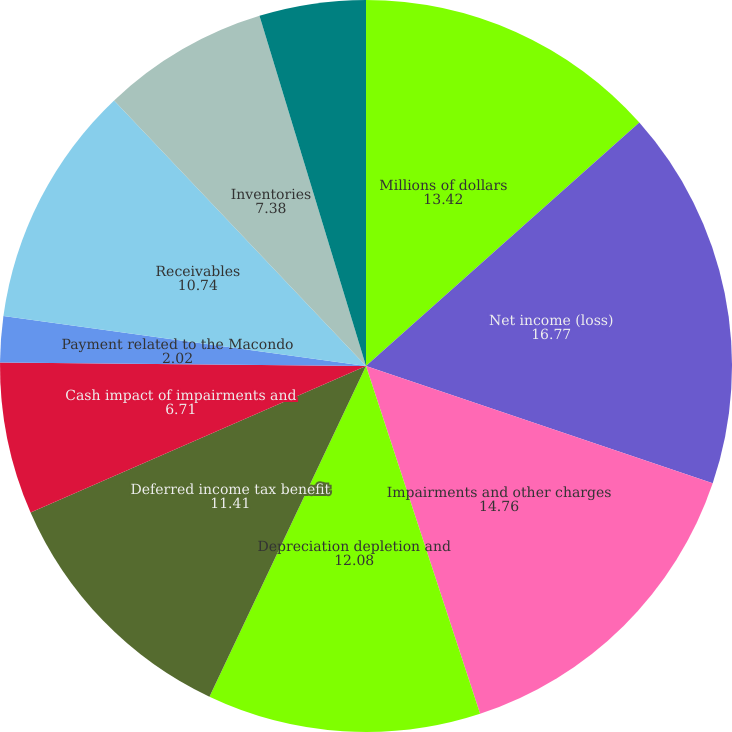<chart> <loc_0><loc_0><loc_500><loc_500><pie_chart><fcel>Millions of dollars<fcel>Net income (loss)<fcel>Impairments and other charges<fcel>Depreciation depletion and<fcel>Deferred income tax benefit<fcel>Cash impact of impairments and<fcel>Payment related to the Macondo<fcel>Receivables<fcel>Inventories<fcel>Accounts payable<nl><fcel>13.42%<fcel>16.77%<fcel>14.76%<fcel>12.08%<fcel>11.41%<fcel>6.71%<fcel>2.02%<fcel>10.74%<fcel>7.38%<fcel>4.7%<nl></chart> 